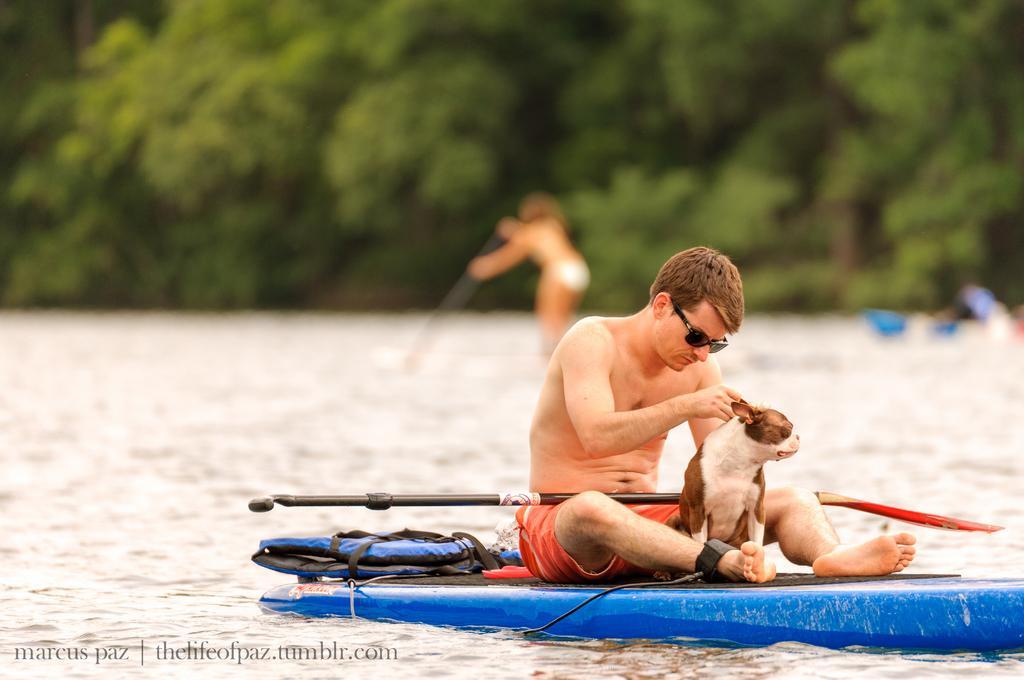Please provide a concise description of this image. In this image in front there is a person with the dog sitting on the surfing board. Behind him there are two other surfing boards. At the bottom there is water. In the background there are trees. 